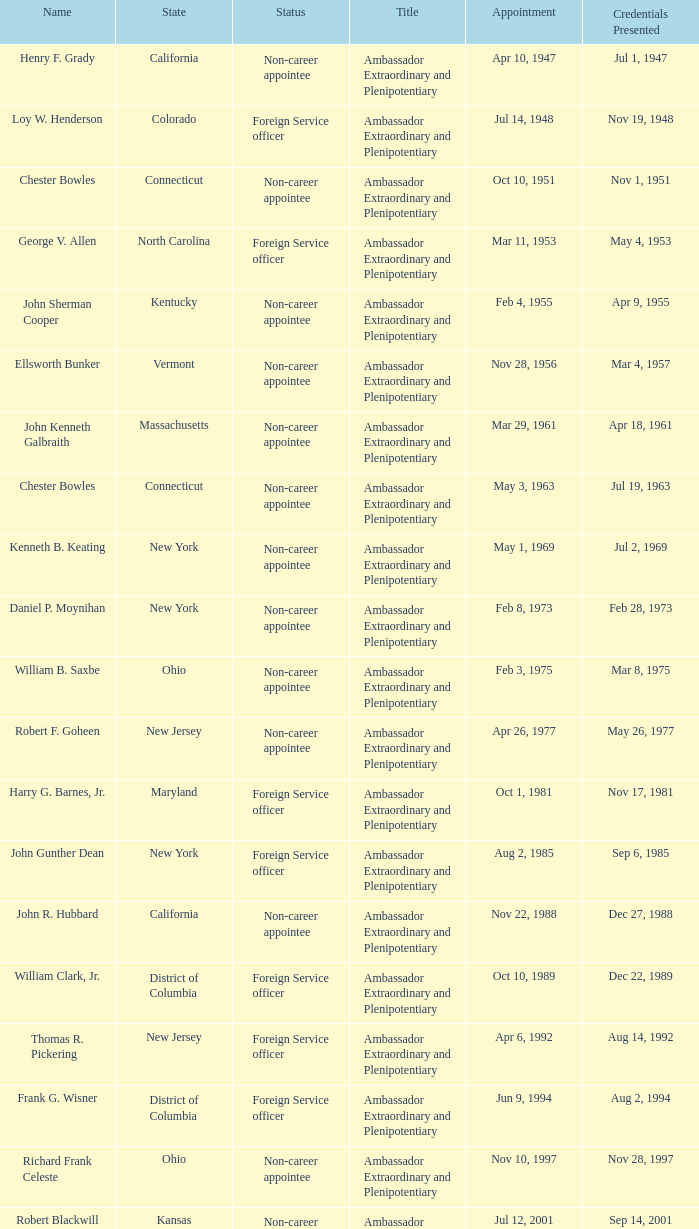What position or designation does david campbell mulford have? Ambassador Extraordinary and Plenipotentiary. Give me the full table as a dictionary. {'header': ['Name', 'State', 'Status', 'Title', 'Appointment', 'Credentials Presented'], 'rows': [['Henry F. Grady', 'California', 'Non-career appointee', 'Ambassador Extraordinary and Plenipotentiary', 'Apr 10, 1947', 'Jul 1, 1947'], ['Loy W. Henderson', 'Colorado', 'Foreign Service officer', 'Ambassador Extraordinary and Plenipotentiary', 'Jul 14, 1948', 'Nov 19, 1948'], ['Chester Bowles', 'Connecticut', 'Non-career appointee', 'Ambassador Extraordinary and Plenipotentiary', 'Oct 10, 1951', 'Nov 1, 1951'], ['George V. Allen', 'North Carolina', 'Foreign Service officer', 'Ambassador Extraordinary and Plenipotentiary', 'Mar 11, 1953', 'May 4, 1953'], ['John Sherman Cooper', 'Kentucky', 'Non-career appointee', 'Ambassador Extraordinary and Plenipotentiary', 'Feb 4, 1955', 'Apr 9, 1955'], ['Ellsworth Bunker', 'Vermont', 'Non-career appointee', 'Ambassador Extraordinary and Plenipotentiary', 'Nov 28, 1956', 'Mar 4, 1957'], ['John Kenneth Galbraith', 'Massachusetts', 'Non-career appointee', 'Ambassador Extraordinary and Plenipotentiary', 'Mar 29, 1961', 'Apr 18, 1961'], ['Chester Bowles', 'Connecticut', 'Non-career appointee', 'Ambassador Extraordinary and Plenipotentiary', 'May 3, 1963', 'Jul 19, 1963'], ['Kenneth B. Keating', 'New York', 'Non-career appointee', 'Ambassador Extraordinary and Plenipotentiary', 'May 1, 1969', 'Jul 2, 1969'], ['Daniel P. Moynihan', 'New York', 'Non-career appointee', 'Ambassador Extraordinary and Plenipotentiary', 'Feb 8, 1973', 'Feb 28, 1973'], ['William B. Saxbe', 'Ohio', 'Non-career appointee', 'Ambassador Extraordinary and Plenipotentiary', 'Feb 3, 1975', 'Mar 8, 1975'], ['Robert F. Goheen', 'New Jersey', 'Non-career appointee', 'Ambassador Extraordinary and Plenipotentiary', 'Apr 26, 1977', 'May 26, 1977'], ['Harry G. Barnes, Jr.', 'Maryland', 'Foreign Service officer', 'Ambassador Extraordinary and Plenipotentiary', 'Oct 1, 1981', 'Nov 17, 1981'], ['John Gunther Dean', 'New York', 'Foreign Service officer', 'Ambassador Extraordinary and Plenipotentiary', 'Aug 2, 1985', 'Sep 6, 1985'], ['John R. Hubbard', 'California', 'Non-career appointee', 'Ambassador Extraordinary and Plenipotentiary', 'Nov 22, 1988', 'Dec 27, 1988'], ['William Clark, Jr.', 'District of Columbia', 'Foreign Service officer', 'Ambassador Extraordinary and Plenipotentiary', 'Oct 10, 1989', 'Dec 22, 1989'], ['Thomas R. Pickering', 'New Jersey', 'Foreign Service officer', 'Ambassador Extraordinary and Plenipotentiary', 'Apr 6, 1992', 'Aug 14, 1992'], ['Frank G. Wisner', 'District of Columbia', 'Foreign Service officer', 'Ambassador Extraordinary and Plenipotentiary', 'Jun 9, 1994', 'Aug 2, 1994'], ['Richard Frank Celeste', 'Ohio', 'Non-career appointee', 'Ambassador Extraordinary and Plenipotentiary', 'Nov 10, 1997', 'Nov 28, 1997'], ['Robert Blackwill', 'Kansas', 'Non-career appointee', 'Ambassador Extraordinary and Plenipotentiary', 'Jul 12, 2001', 'Sep 14, 2001'], ['David Campbell Mulford', 'Illinois', 'Non-career officer', 'Ambassador Extraordinary and Plenipotentiary', 'Dec 12, 2003', 'Feb 23, 2004'], ['Timothy J. Roemer', 'Indiana', 'Non-career appointee', 'Ambassador Extraordinary and Plenipotentiary', 'Jul 23, 2009', 'Aug 11, 2009'], ['Albert Peter Burleigh', 'California', 'Foreign Service officer', "Charge d'affaires", 'June 2011', 'Left post 2012'], ['Nancy Jo Powell', 'Iowa', 'Foreign Service officer', 'Ambassador Extraordinary and Plenipotentiary', 'February 7, 2012', 'April 19, 2012']]} 